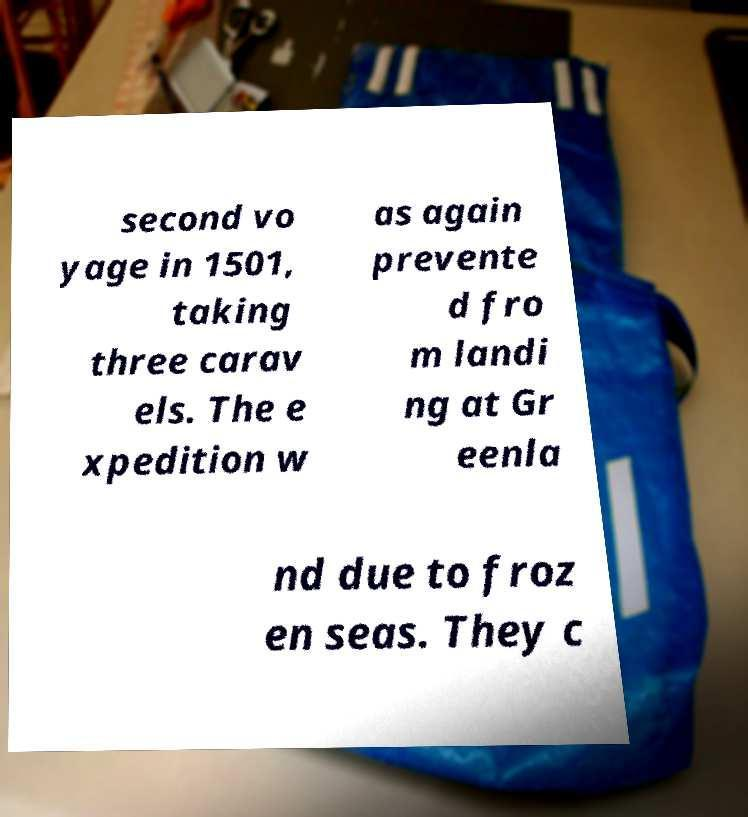Could you assist in decoding the text presented in this image and type it out clearly? second vo yage in 1501, taking three carav els. The e xpedition w as again prevente d fro m landi ng at Gr eenla nd due to froz en seas. They c 